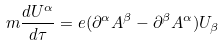Convert formula to latex. <formula><loc_0><loc_0><loc_500><loc_500>m \frac { d U ^ { \alpha } } { d \tau } = e ( \partial ^ { \alpha } A ^ { \beta } - \partial ^ { \beta } A ^ { \alpha } ) U _ { \beta }</formula> 